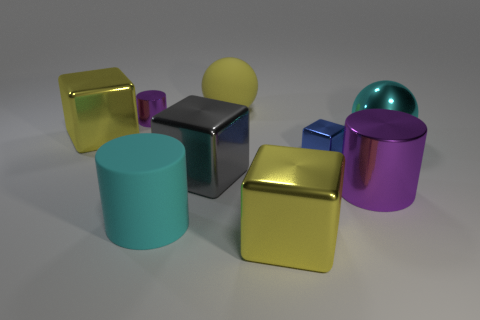Can you tell me how many objects in the image have a glossy finish? Certainly, there are four objects in the image with a glossy finish. This includes the big cyan cylinder, the sphere beside it, the small blue cube, and the purple cylinder. Their surfaces reflect light smoothly, indicating a glossy texture.  Could you estimate the relative sizes of these glossy objects? While precise measurements are not possible from this image alone, the big cyan cylinder appears to be the largest of the glossy items. The purple cylinder seems to be the next in size, followed by the yellow sphere, and lastly, the small blue cube appears to be the smallest. 